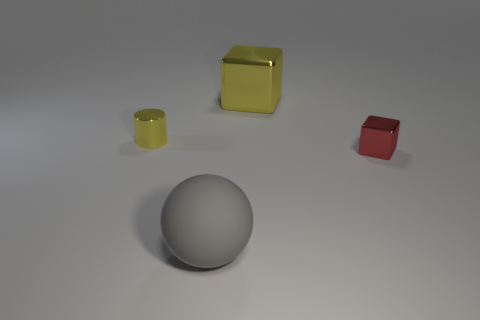Add 2 yellow metallic cubes. How many objects exist? 6 Subtract all cylinders. How many objects are left? 3 Subtract all red blocks. How many blocks are left? 1 Subtract 0 gray blocks. How many objects are left? 4 Subtract 1 blocks. How many blocks are left? 1 Subtract all blue cylinders. Subtract all yellow spheres. How many cylinders are left? 1 Subtract all yellow cylinders. Subtract all cubes. How many objects are left? 1 Add 2 blocks. How many blocks are left? 4 Add 1 big gray rubber objects. How many big gray rubber objects exist? 2 